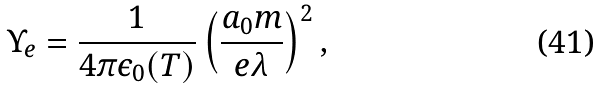Convert formula to latex. <formula><loc_0><loc_0><loc_500><loc_500>\Upsilon _ { e } = \frac { 1 } { 4 \pi \epsilon _ { 0 } ( T ) } \left ( \frac { a _ { 0 } m } { e \lambda } \right ) ^ { 2 } ,</formula> 